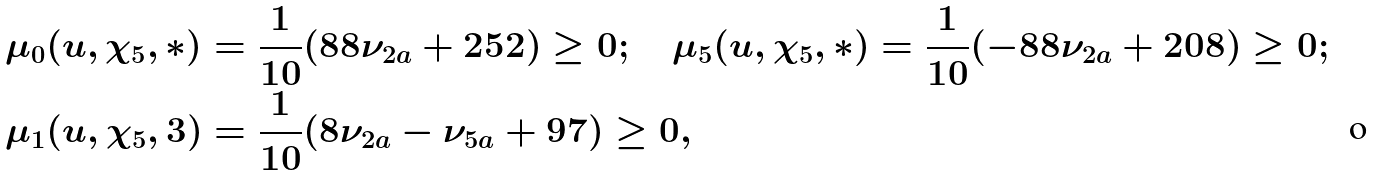<formula> <loc_0><loc_0><loc_500><loc_500>\mu _ { 0 } ( u , \chi _ { 5 } , * ) & = \frac { 1 } { 1 0 } ( 8 8 \nu _ { 2 a } + 2 5 2 ) \geq 0 ; \quad \mu _ { 5 } ( u , \chi _ { 5 } , * ) = \frac { 1 } { 1 0 } ( - 8 8 \nu _ { 2 a } + 2 0 8 ) \geq 0 ; \\ \mu _ { 1 } ( u , \chi _ { 5 } , 3 ) & = \frac { 1 } { 1 0 } ( 8 \nu _ { 2 a } - \nu _ { 5 a } + 9 7 ) \geq 0 , \\</formula> 